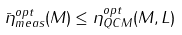Convert formula to latex. <formula><loc_0><loc_0><loc_500><loc_500>\bar { \eta } _ { m e a s } ^ { o p t } ( M ) \leq \eta _ { Q C M } ^ { o p t } ( M , L ) \ \</formula> 